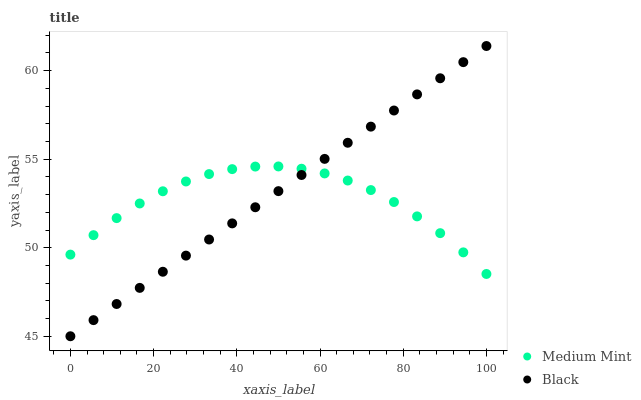Does Medium Mint have the minimum area under the curve?
Answer yes or no. Yes. Does Black have the maximum area under the curve?
Answer yes or no. Yes. Does Black have the minimum area under the curve?
Answer yes or no. No. Is Black the smoothest?
Answer yes or no. Yes. Is Medium Mint the roughest?
Answer yes or no. Yes. Is Black the roughest?
Answer yes or no. No. Does Black have the lowest value?
Answer yes or no. Yes. Does Black have the highest value?
Answer yes or no. Yes. Does Black intersect Medium Mint?
Answer yes or no. Yes. Is Black less than Medium Mint?
Answer yes or no. No. Is Black greater than Medium Mint?
Answer yes or no. No. 